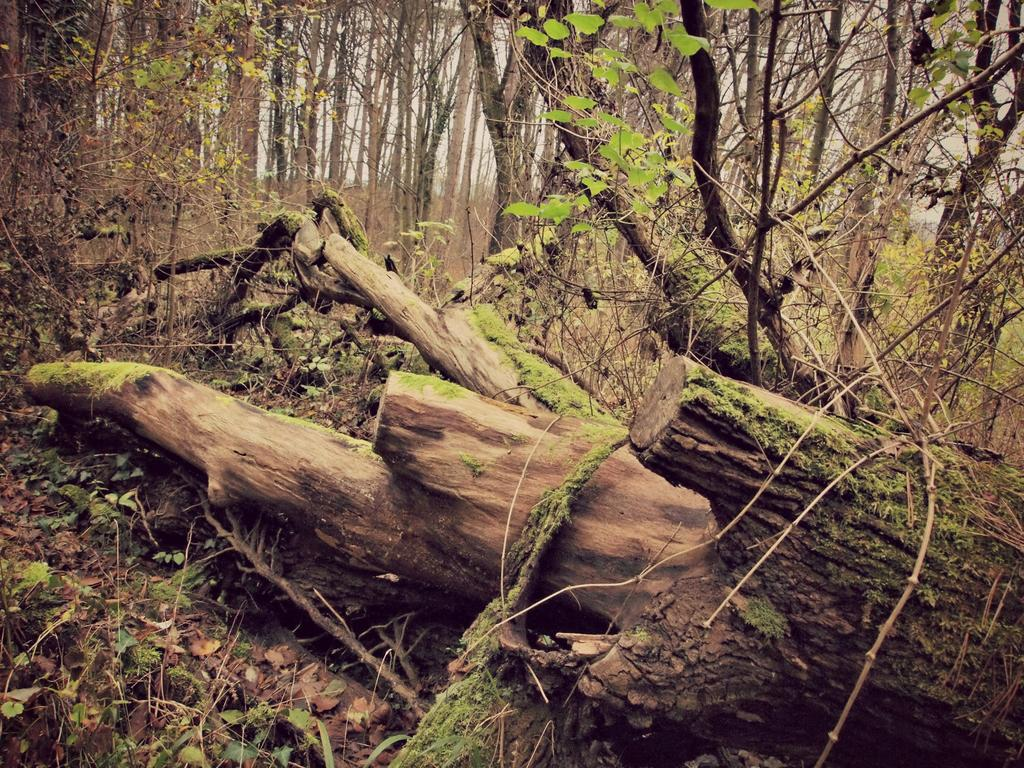Where was the image taken? The image was clicked outside the city. What can be seen in the foreground of the image? There are tree trunks lying on the ground in the foreground. What is visible in the background of the image? There are trees and plants in the background. How many dogs are visible in the image? There are no dogs present in the image. What type of plane can be seen flying in the background? There is no plane visible in the image. 